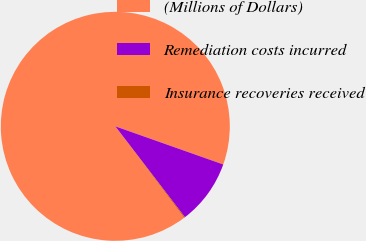<chart> <loc_0><loc_0><loc_500><loc_500><pie_chart><fcel>(Millions of Dollars)<fcel>Remediation costs incurred<fcel>Insurance recoveries received<nl><fcel>90.67%<fcel>9.19%<fcel>0.14%<nl></chart> 